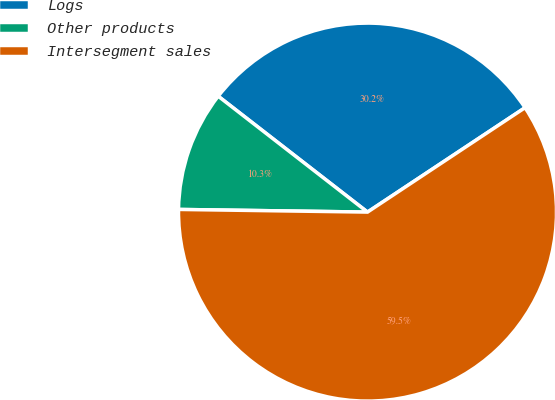Convert chart to OTSL. <chart><loc_0><loc_0><loc_500><loc_500><pie_chart><fcel>Logs<fcel>Other products<fcel>Intersegment sales<nl><fcel>30.18%<fcel>10.28%<fcel>59.54%<nl></chart> 